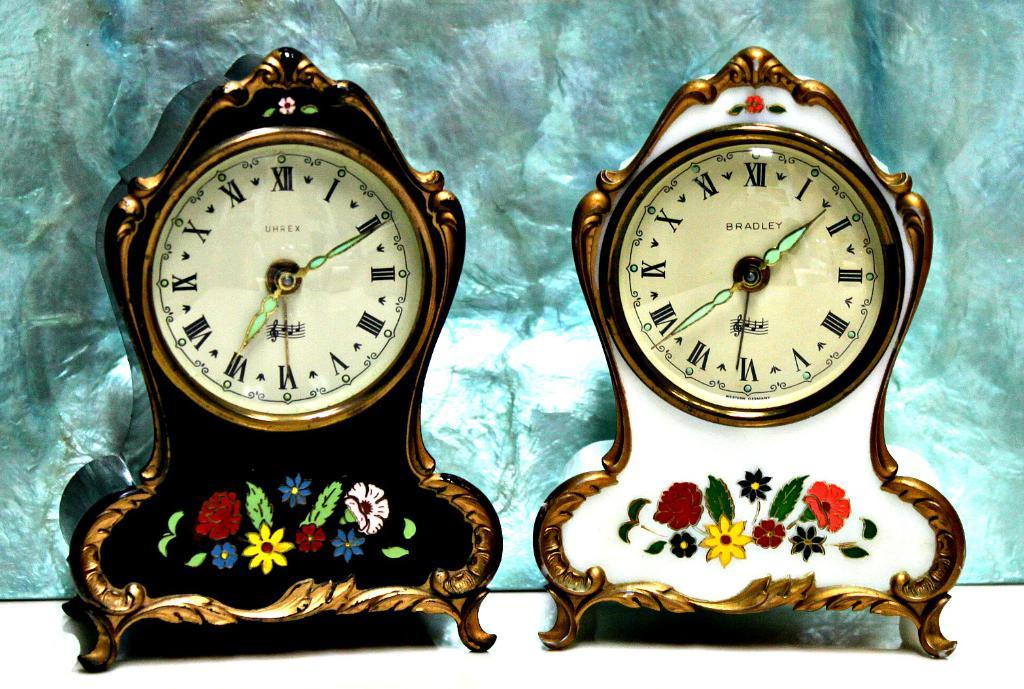<image>
Summarize the visual content of the image. An old UHREX clock next to an old BRADLEY clock. 